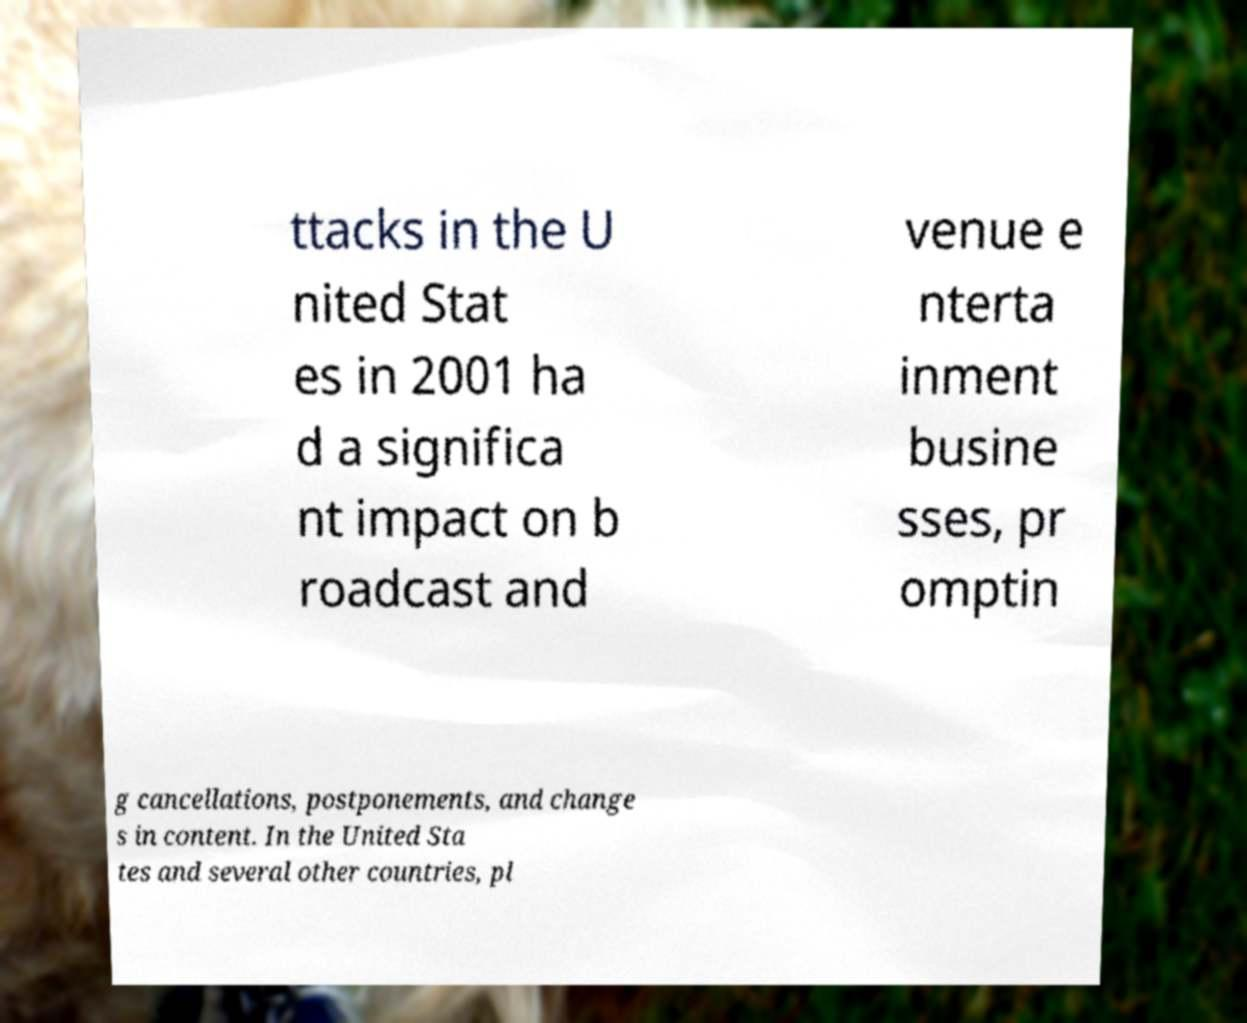I need the written content from this picture converted into text. Can you do that? ttacks in the U nited Stat es in 2001 ha d a significa nt impact on b roadcast and venue e nterta inment busine sses, pr omptin g cancellations, postponements, and change s in content. In the United Sta tes and several other countries, pl 